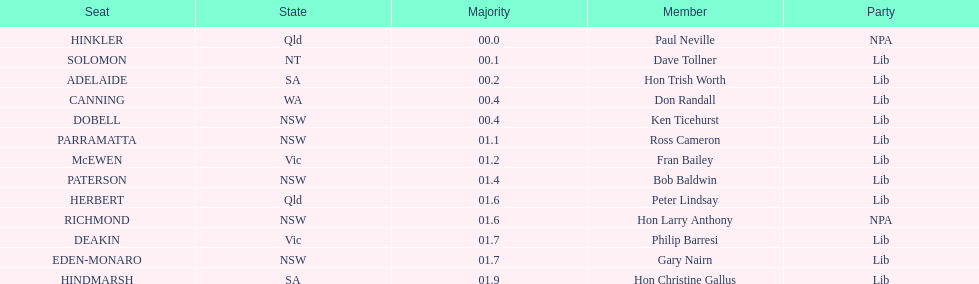Tell me the number of seats from nsw? 5. 